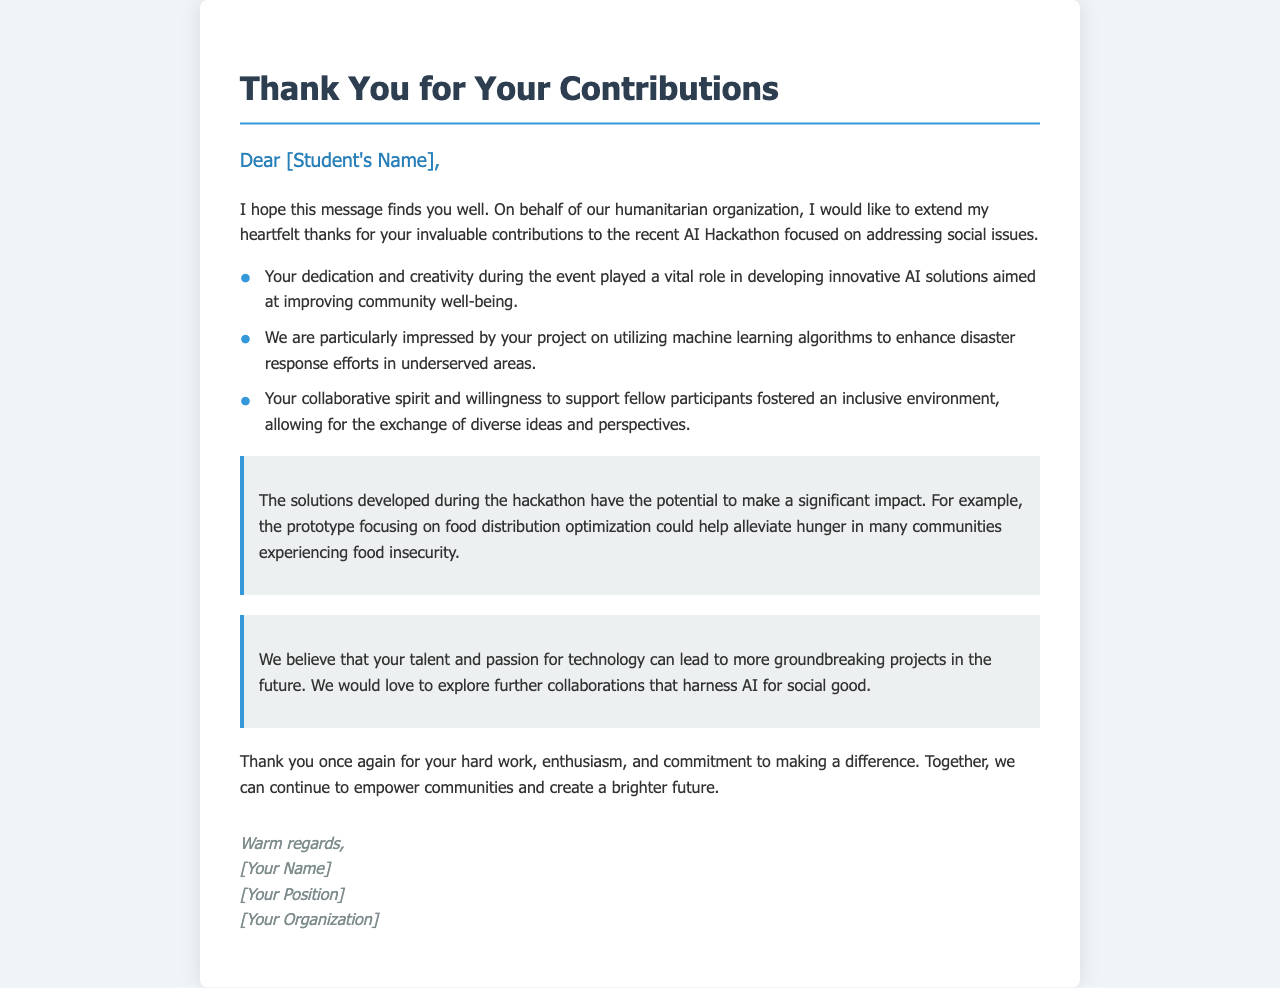What is the purpose of the letter? The purpose of the letter is to extend thanks to students for their contributions to the AI Hackathon.
Answer: Thank you for your contributions Who is the letter addressed to? The letter is addressed to individual undergraduate students, indicated by [Student's Name].
Answer: [Student's Name] What type of projects were highlighted in the letter? The projects highlighted in the letter include AI solutions for social issues, specifically mentioning disaster response efforts.
Answer: AI solutions for social issues Which algorithm type was mentioned in relation to the student's project? The letter mentions machine learning algorithms in the context of enhancing disaster response efforts.
Answer: Machine learning algorithms What impact is noted about the hackathon solutions? It is noted that the solutions developed have the potential to significantly impact community well-being, specifically in food distribution.
Answer: Significant impact What is suggested for future collaboration? The letter expresses a desire to explore further collaborations that harness AI for social good.
Answer: Further collaborations What is the tone of the letter? The tone of the letter is appreciative and encouraging, recognizing the students' hard work and contributions.
Answer: Appreciative and encouraging What organizational role is represented by the sender of the letter? The sender's role is indicated as a representative of a humanitarian organization.
Answer: Humanitarian organization 